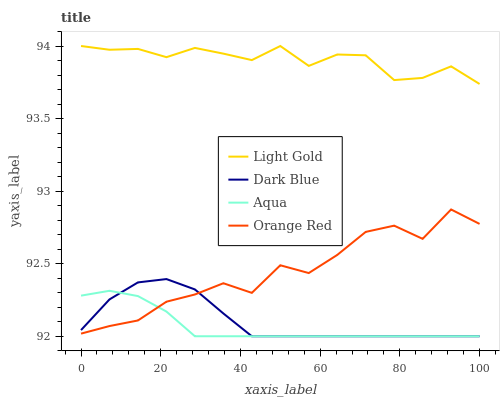Does Aqua have the minimum area under the curve?
Answer yes or no. Yes. Does Light Gold have the maximum area under the curve?
Answer yes or no. Yes. Does Dark Blue have the minimum area under the curve?
Answer yes or no. No. Does Dark Blue have the maximum area under the curve?
Answer yes or no. No. Is Aqua the smoothest?
Answer yes or no. Yes. Is Orange Red the roughest?
Answer yes or no. Yes. Is Dark Blue the smoothest?
Answer yes or no. No. Is Dark Blue the roughest?
Answer yes or no. No. Does Aqua have the lowest value?
Answer yes or no. Yes. Does Light Gold have the lowest value?
Answer yes or no. No. Does Light Gold have the highest value?
Answer yes or no. Yes. Does Dark Blue have the highest value?
Answer yes or no. No. Is Dark Blue less than Light Gold?
Answer yes or no. Yes. Is Light Gold greater than Orange Red?
Answer yes or no. Yes. Does Dark Blue intersect Orange Red?
Answer yes or no. Yes. Is Dark Blue less than Orange Red?
Answer yes or no. No. Is Dark Blue greater than Orange Red?
Answer yes or no. No. Does Dark Blue intersect Light Gold?
Answer yes or no. No. 